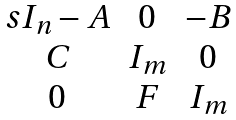Convert formula to latex. <formula><loc_0><loc_0><loc_500><loc_500>\begin{matrix} s I _ { n } - A & 0 & - B \\ C & I _ { m } & 0 \\ 0 & F & I _ { m } \end{matrix}</formula> 